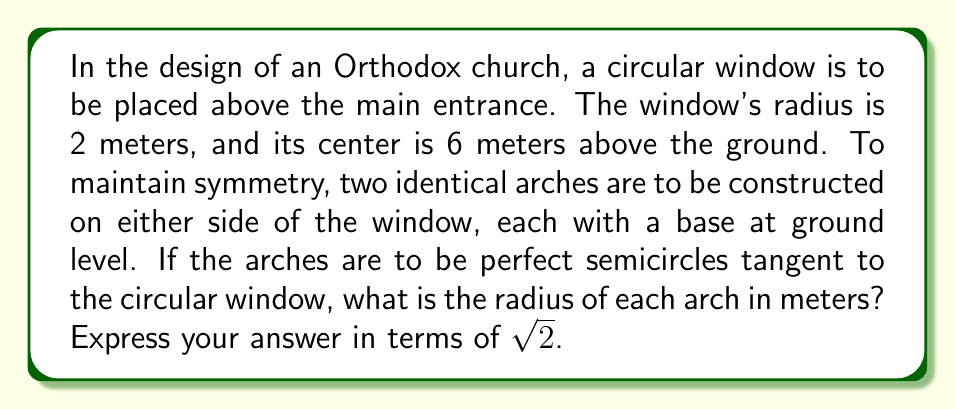Teach me how to tackle this problem. Let's approach this step-by-step:

1) Let the radius of each arch be $r$ meters.

2) The center of each arch will be $r$ meters from the ground and $r$ meters from the central vertical line of the church facade.

3) The center of the circular window is 6 meters above the ground and on the central vertical line.

4) For the arch to be tangent to the window, the distance between their centers must equal the sum of their radii.

5) We can use the Pythagorean theorem to find this distance:

   $$\text{distance}^2 = r^2 + (6-r)^2$$

6) This distance should equal $r + 2$ (sum of radii):

   $$\sqrt{r^2 + (6-r)^2} = r + 2$$

7) Square both sides:

   $$r^2 + (6-r)^2 = r^2 + 4r + 4$$

8) Expand the left side:

   $$r^2 + 36 - 12r + r^2 = r^2 + 4r + 4$$

9) Simplify:

   $$2r^2 - 12r + 36 = r^2 + 4r + 4$$

10) Subtract $r^2 + 4r + 4$ from both sides:

    $$r^2 - 16r + 32 = 0$$

11) This is a quadratic equation. We can solve it using the quadratic formula:

    $$r = \frac{16 \pm \sqrt{256 - 4(1)(32)}}{2(1)} = \frac{16 \pm \sqrt{128}}{2} = 8 \pm 4\sqrt{2}$$

12) Since the radius must be positive, we take the positive solution:

    $$r = 8 + 4\sqrt{2}$$

Therefore, the radius of each arch is $8 + 4\sqrt{2}$ meters.
Answer: $8 + 4\sqrt{2}$ meters 